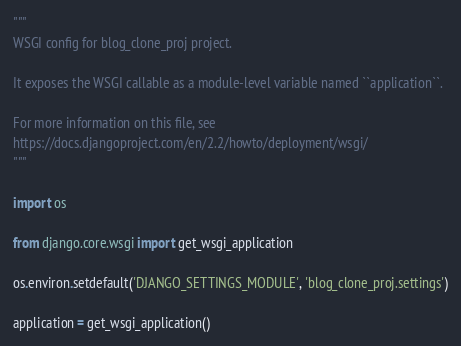Convert code to text. <code><loc_0><loc_0><loc_500><loc_500><_Python_>"""
WSGI config for blog_clone_proj project.

It exposes the WSGI callable as a module-level variable named ``application``.

For more information on this file, see
https://docs.djangoproject.com/en/2.2/howto/deployment/wsgi/
"""

import os

from django.core.wsgi import get_wsgi_application

os.environ.setdefault('DJANGO_SETTINGS_MODULE', 'blog_clone_proj.settings')

application = get_wsgi_application()
</code> 